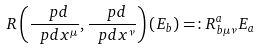<formula> <loc_0><loc_0><loc_500><loc_500>R \left ( \frac { \ p d } { \ p d x ^ { \mu } } , \frac { \ p d } { \ p d x ^ { \nu } } \right ) ( E _ { b } ) = \colon R _ { b \mu \nu } ^ { a } E _ { a }</formula> 